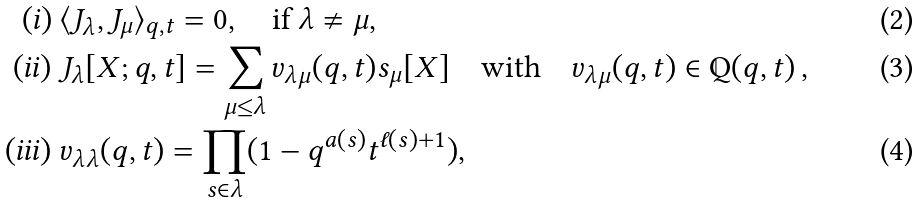<formula> <loc_0><loc_0><loc_500><loc_500>( i ) \ & \langle J _ { \lambda } , J _ { \mu } \rangle _ { q , t } = 0 , \quad \text {if } \lambda \ne \mu , \\ ( i i ) \ & J _ { \lambda } [ X ; q , t ] = \sum _ { \mu \leq \lambda } v _ { \lambda \mu } ( q , t ) s _ { \mu } [ X ] \quad \text {with} \quad v _ { \lambda \mu } ( q , t ) \in \mathbb { Q } ( q , t ) \, , \\ ( i i i ) \ & v _ { \lambda \lambda } ( q , t ) = \prod _ { s \in \lambda } ( 1 - q ^ { a ( s ) } t ^ { \ell ( s ) + 1 } ) ,</formula> 